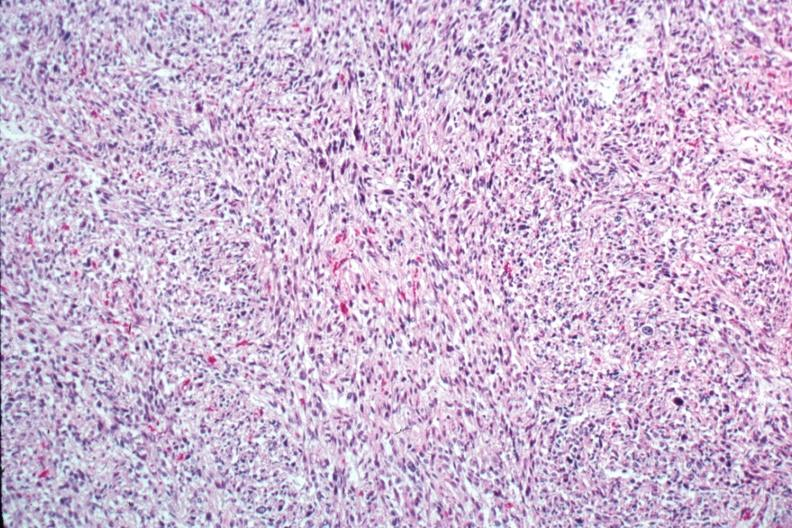what does this image show?
Answer the question using a single word or phrase. Excellent photo of pleomorphic spindle cell tumor with storiform pattern 